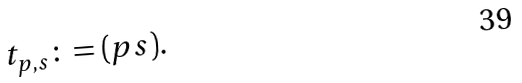Convert formula to latex. <formula><loc_0><loc_0><loc_500><loc_500>t _ { p , s } \colon = ( p s ) .</formula> 